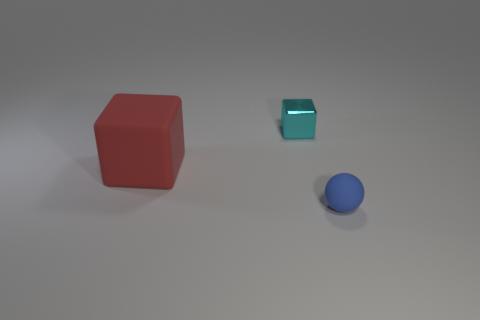There is a cyan thing that is the same shape as the red thing; what material is it?
Your answer should be very brief. Metal. How many objects are either objects in front of the cyan thing or cyan metallic blocks?
Offer a terse response. 3. There is a small blue thing that is the same material as the big cube; what shape is it?
Your answer should be compact. Sphere. How many red things have the same shape as the tiny cyan object?
Provide a short and direct response. 1. What material is the ball?
Your response must be concise. Rubber. What number of cylinders are matte objects or yellow objects?
Offer a terse response. 0. What is the color of the rubber thing in front of the red rubber block?
Ensure brevity in your answer.  Blue. What number of blue things have the same size as the rubber block?
Ensure brevity in your answer.  0. Is the shape of the matte object that is left of the cyan thing the same as the tiny object on the left side of the blue matte ball?
Give a very brief answer. Yes. What material is the object that is in front of the rubber thing behind the small thing in front of the red rubber thing made of?
Provide a succinct answer. Rubber. 